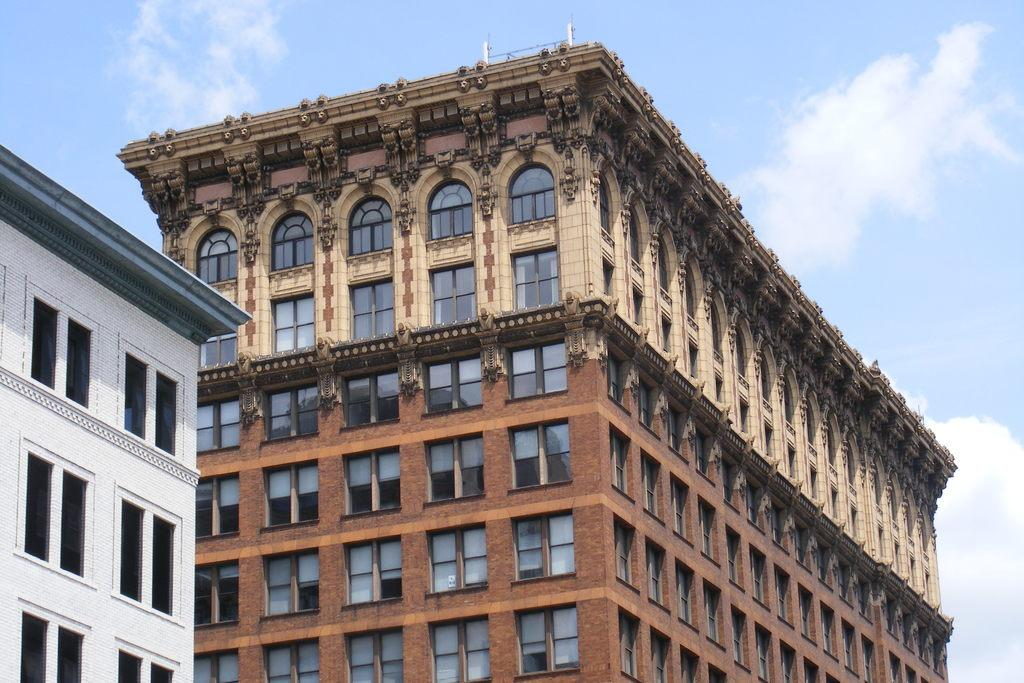What is the main subject in the center of the image? There are buildings in the center of the image. What can be seen in the background of the image? The sky is visible in the background of the image. What type of voice can be heard coming from the buildings in the image? There is no voice present in the image, as it is a still image of buildings and the sky. 